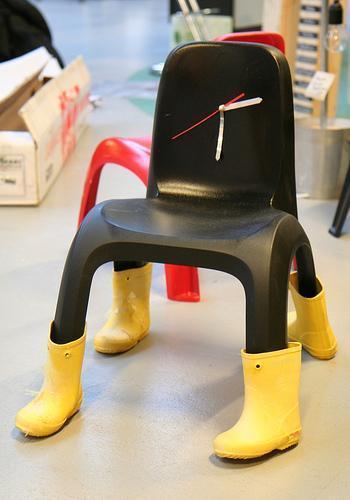How many yellow boots?
Give a very brief answer. 4. How many boots are facing forward relative to the chair?
Give a very brief answer. 3. How many chairs are in the picture?
Give a very brief answer. 2. 